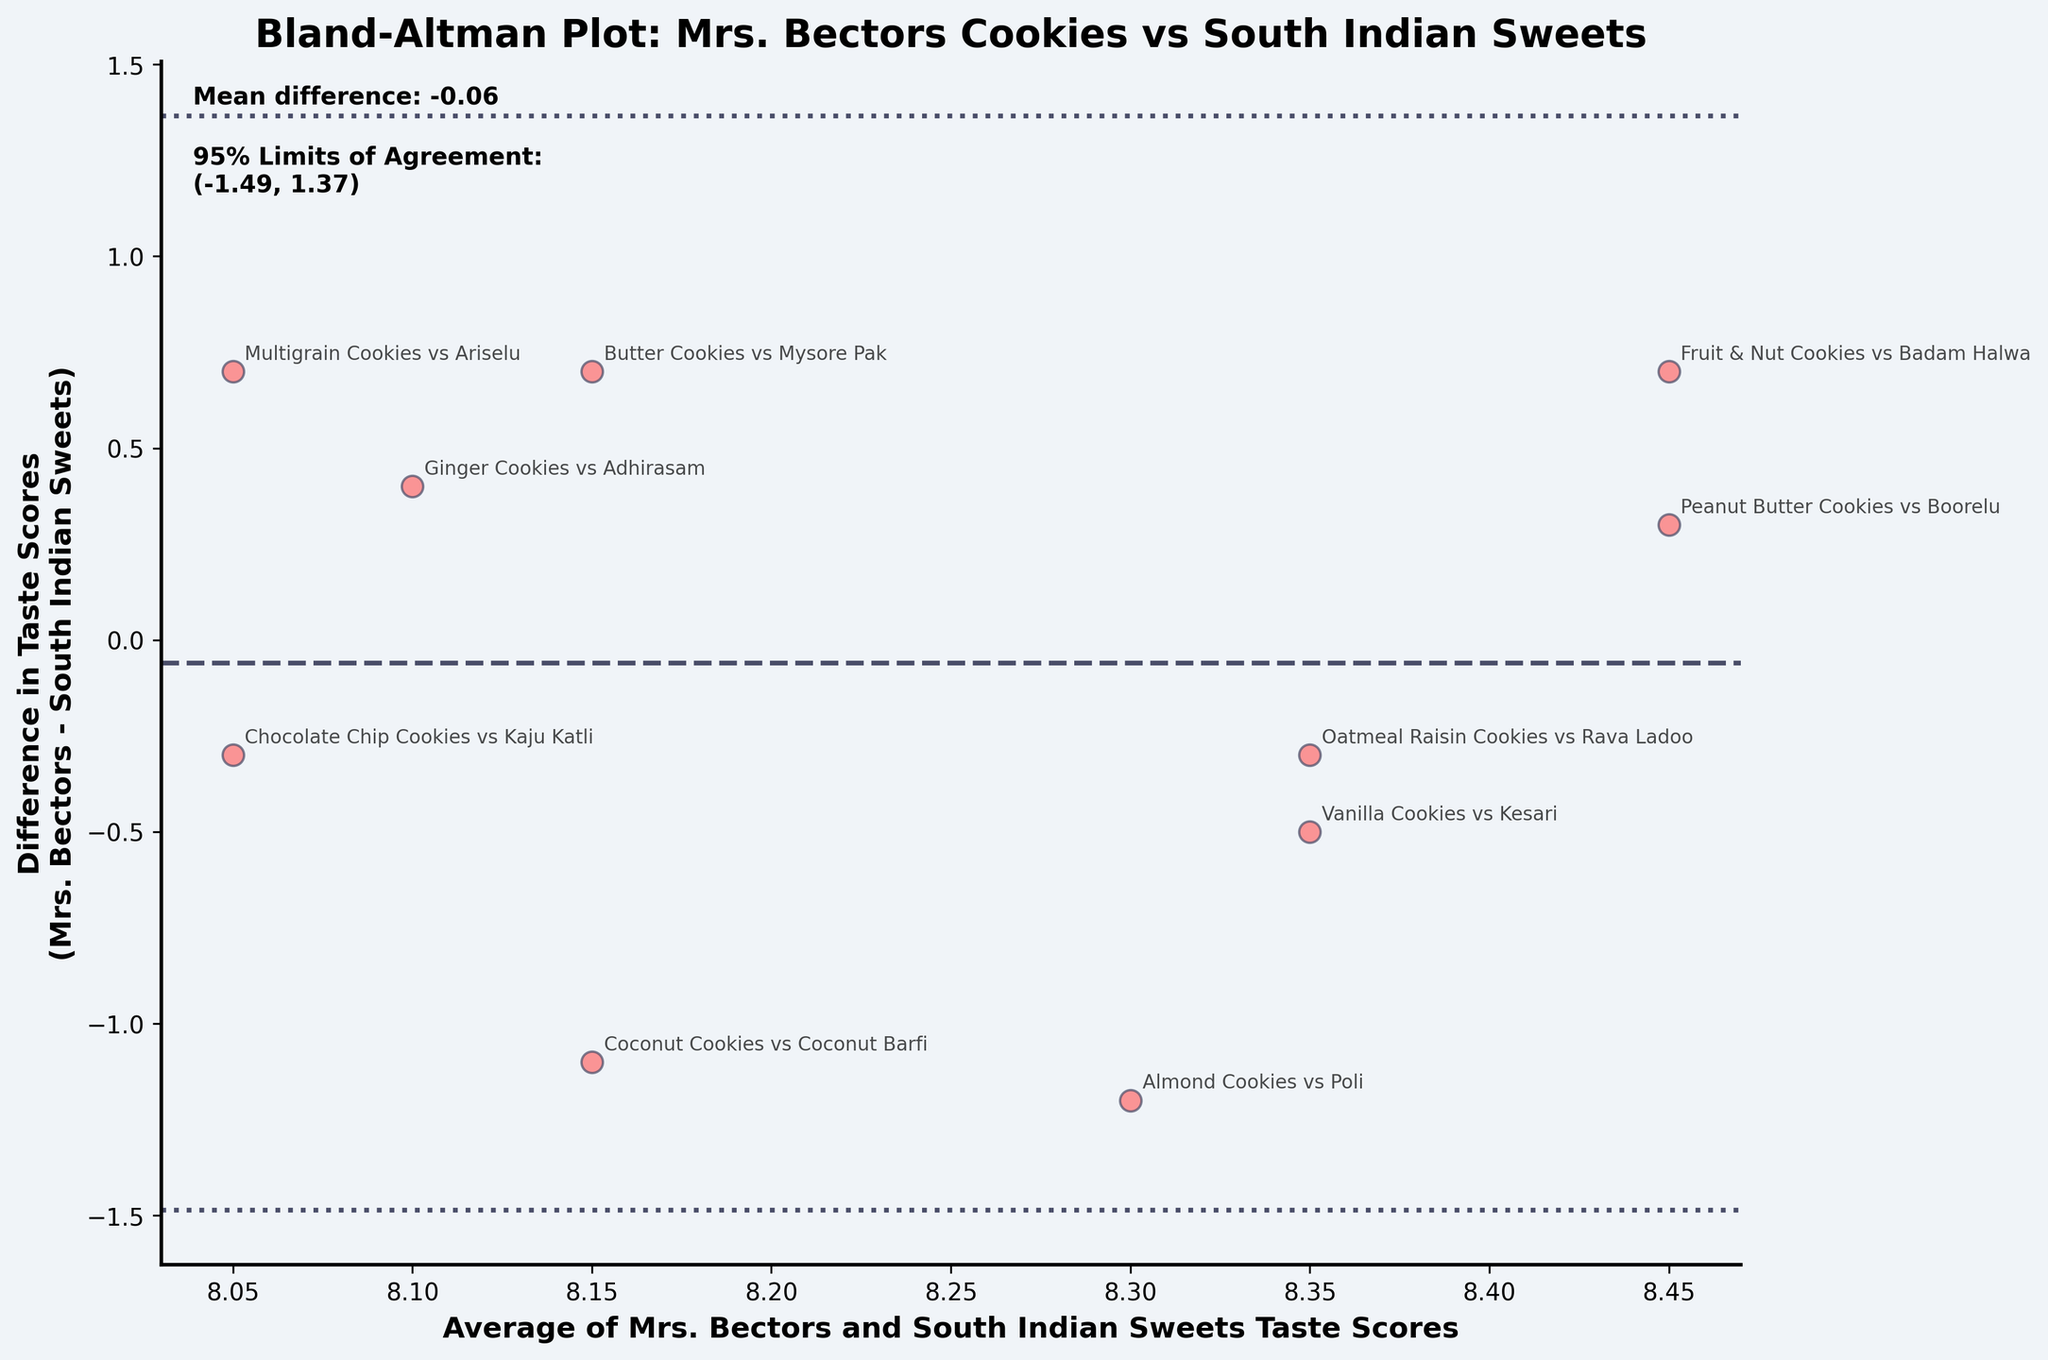What is the title of the plot? The title is displayed prominently at the top of the plot to provide an overview of the figure.
Answer: Bland-Altman Plot: Mrs. Bectors Cookies vs South Indian Sweets How are the data points represented in the plot? The data points are represented as scatter points with a specific color and edge colors in the plot.
Answer: Scatter points with red color and black edges What is plotted on the x-axis? The x-axis represents the average of the taste scores for Mrs. Bectors cookies and South Indian sweets.
Answer: Average of Mrs. Bectors and South Indian Sweets Taste Scores What does the y-axis represent? The y-axis indicates the difference between the taste scores of Mrs. Bectors cookies and South Indian sweets.
Answer: Difference in Taste Scores (Mrs. Bectors - South Indian Sweets) What is the mean difference in taste scores? The mean difference is indicated by a horizontal line and text annotation on the plot.
Answer: Mean difference: -0.36 What are the 95% Limits of Agreement? The 95% Limits of Agreement are indicated by two dashed horizontal lines and text annotation on the plot.
Answer: (-1.56, 0.84) Which data point has the largest positive difference in taste scores? The data points are annotated with the types of cookies and sweets, and the vertical distance from 0 indicates the difference.
Answer: Almond Cookies vs Poli Which data point has the closest taste scores? Look for the data point closest to the horizontal line representing zero difference in taste scores.
Answer: Peanut Butter Cookies vs Boorelu What color is used for the background of the plot area? The color of the plot area's background is consistent throughout to provide contrast with the data points.
Answer: Light grey (near white) How is the mean difference line visually distinguished from the 95% Limits of Agreement lines? The mean difference line is a dashed line while the 95% Limits of Agreement lines are dotted.
Answer: Dashed line vs. Dotted lines 